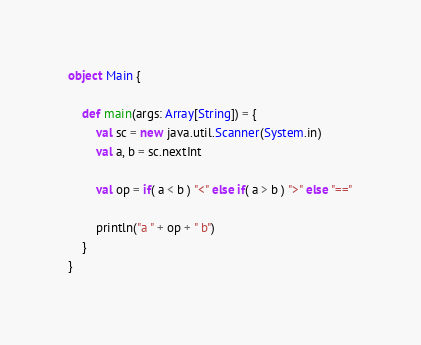Convert code to text. <code><loc_0><loc_0><loc_500><loc_500><_Scala_>object Main {

    def main(args: Array[String]) = {
        val sc = new java.util.Scanner(System.in)
        val a, b = sc.nextInt

        val op = if( a < b ) "<" else if( a > b ) ">" else "=="

        println("a " + op + " b")
    }
}

</code> 